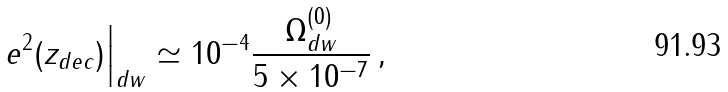Convert formula to latex. <formula><loc_0><loc_0><loc_500><loc_500>e ^ { 2 } ( z _ { d e c } ) \Big | _ { d w } \simeq 1 0 ^ { - 4 } \frac { \Omega _ { d w } ^ { ( 0 ) } } { 5 \times 1 0 ^ { - 7 } } \, ,</formula> 